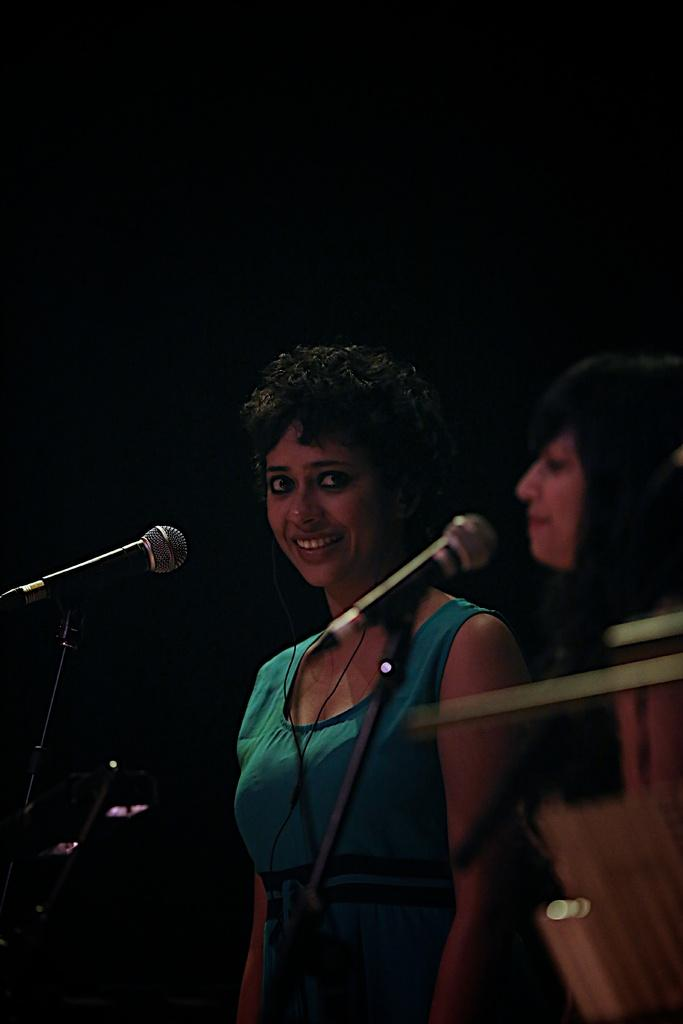How many people are in the image? There are two ladies in the image. Where are the ladies located in the image? The ladies are on the right side of the image. What objects are in front of the ladies? There are microphones in front of the ladies. What is the lady on the right wearing? One of the ladies is wearing a blue t-shirt. What is the facial expression of the lady in the blue t-shirt? The lady in the blue t-shirt is smiling. What type of agreement is being discussed by the lizards in the image? There are no lizards present in the image; it features two ladies with microphones. 